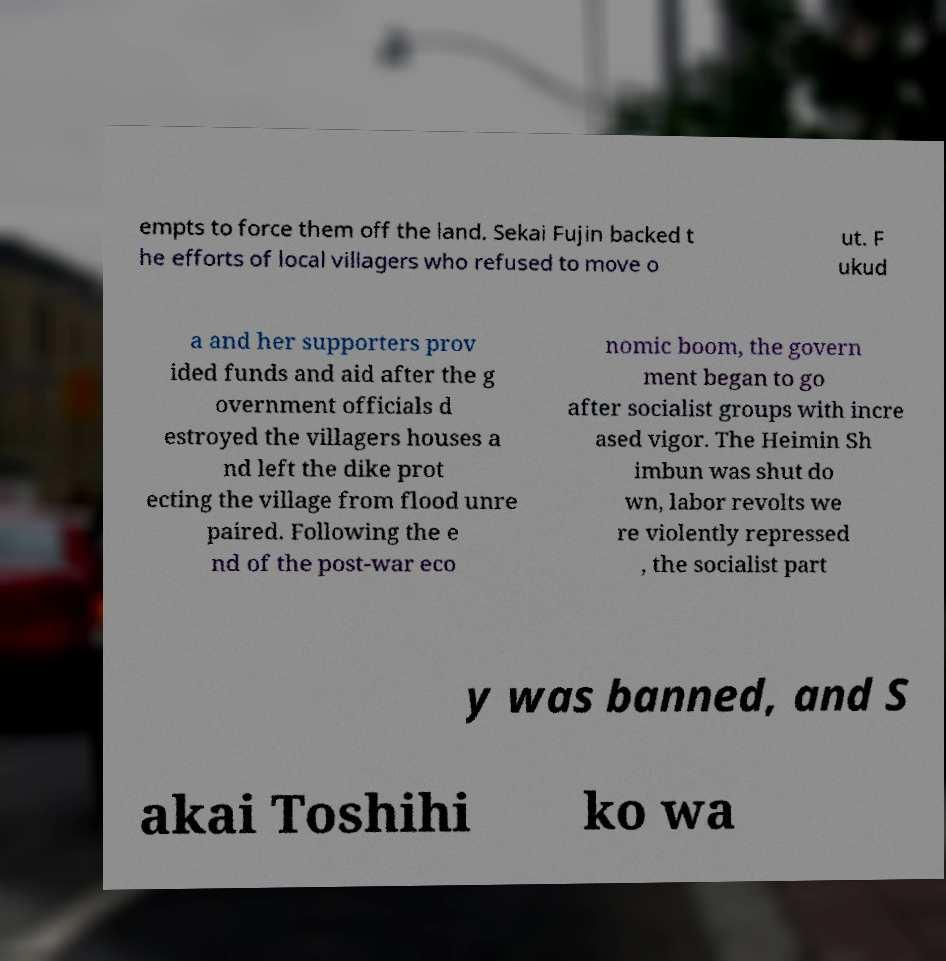Can you read and provide the text displayed in the image?This photo seems to have some interesting text. Can you extract and type it out for me? empts to force them off the land. Sekai Fujin backed t he efforts of local villagers who refused to move o ut. F ukud a and her supporters prov ided funds and aid after the g overnment officials d estroyed the villagers houses a nd left the dike prot ecting the village from flood unre paired. Following the e nd of the post-war eco nomic boom, the govern ment began to go after socialist groups with incre ased vigor. The Heimin Sh imbun was shut do wn, labor revolts we re violently repressed , the socialist part y was banned, and S akai Toshihi ko wa 